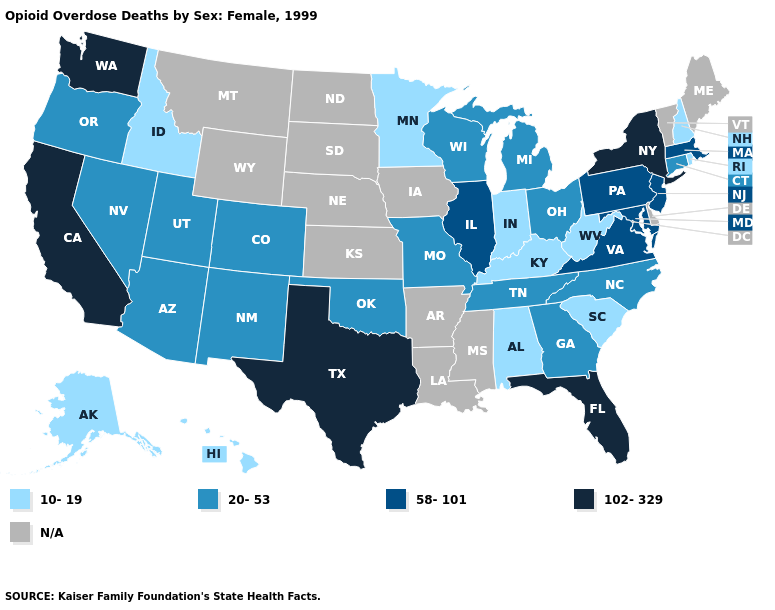What is the highest value in the MidWest ?
Write a very short answer. 58-101. Does West Virginia have the lowest value in the USA?
Keep it brief. Yes. Name the states that have a value in the range 58-101?
Concise answer only. Illinois, Maryland, Massachusetts, New Jersey, Pennsylvania, Virginia. Which states have the highest value in the USA?
Answer briefly. California, Florida, New York, Texas, Washington. Does the first symbol in the legend represent the smallest category?
Write a very short answer. Yes. Which states have the lowest value in the USA?
Write a very short answer. Alabama, Alaska, Hawaii, Idaho, Indiana, Kentucky, Minnesota, New Hampshire, Rhode Island, South Carolina, West Virginia. Which states have the lowest value in the USA?
Be succinct. Alabama, Alaska, Hawaii, Idaho, Indiana, Kentucky, Minnesota, New Hampshire, Rhode Island, South Carolina, West Virginia. Name the states that have a value in the range 58-101?
Write a very short answer. Illinois, Maryland, Massachusetts, New Jersey, Pennsylvania, Virginia. What is the lowest value in the Northeast?
Give a very brief answer. 10-19. Does the first symbol in the legend represent the smallest category?
Quick response, please. Yes. Which states hav the highest value in the Northeast?
Concise answer only. New York. What is the lowest value in the USA?
Write a very short answer. 10-19. What is the value of Mississippi?
Short answer required. N/A. What is the lowest value in the West?
Write a very short answer. 10-19. 